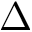Convert formula to latex. <formula><loc_0><loc_0><loc_500><loc_500>\Delta</formula> 